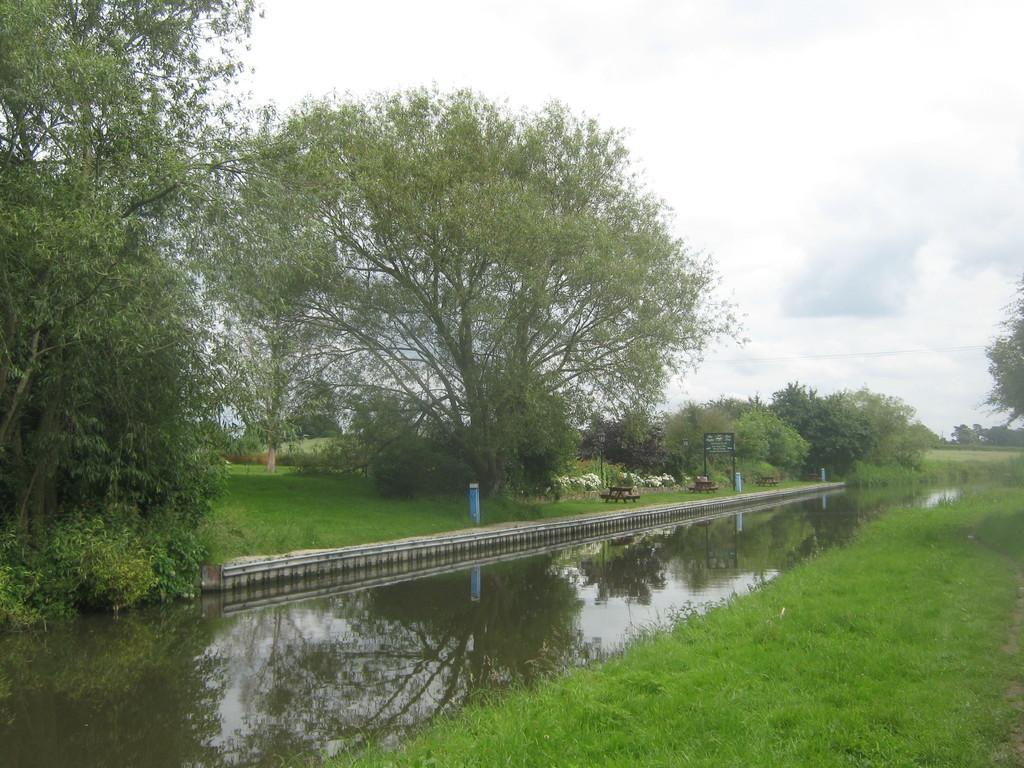How would you summarize this image in a sentence or two? In this image there is so much of water in the middle beside that there are so many trees, grass, building and some other objects. 